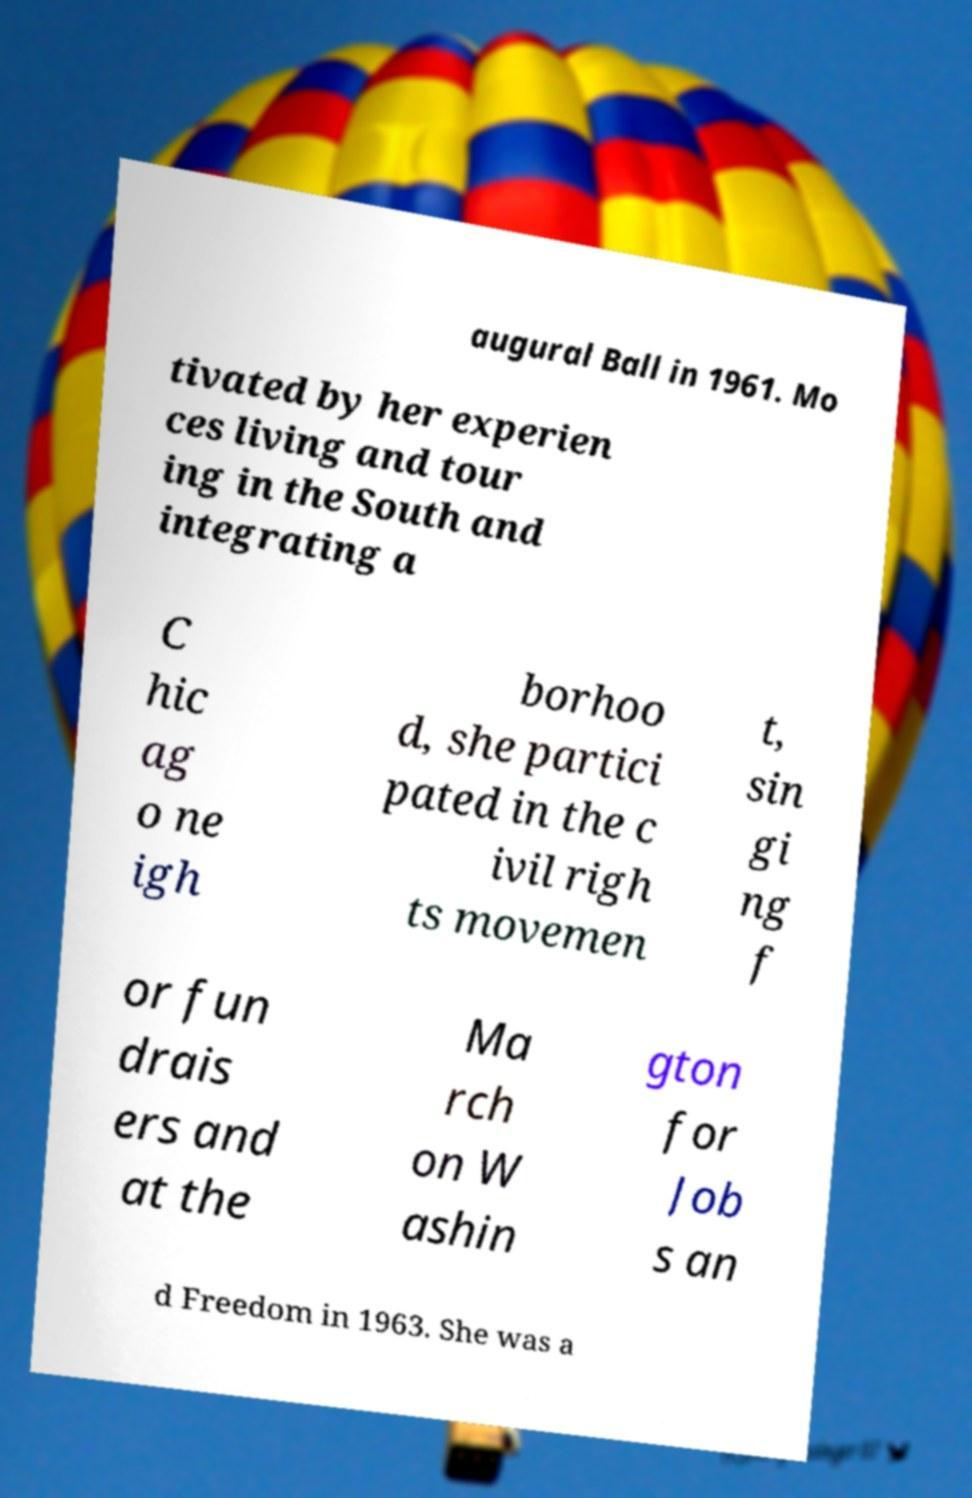Please read and relay the text visible in this image. What does it say? augural Ball in 1961. Mo tivated by her experien ces living and tour ing in the South and integrating a C hic ag o ne igh borhoo d, she partici pated in the c ivil righ ts movemen t, sin gi ng f or fun drais ers and at the Ma rch on W ashin gton for Job s an d Freedom in 1963. She was a 